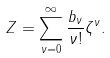Convert formula to latex. <formula><loc_0><loc_0><loc_500><loc_500>Z = \sum _ { \nu = 0 } ^ { \infty } \frac { b _ { \nu } } { \nu ! } \zeta ^ { \nu } .</formula> 